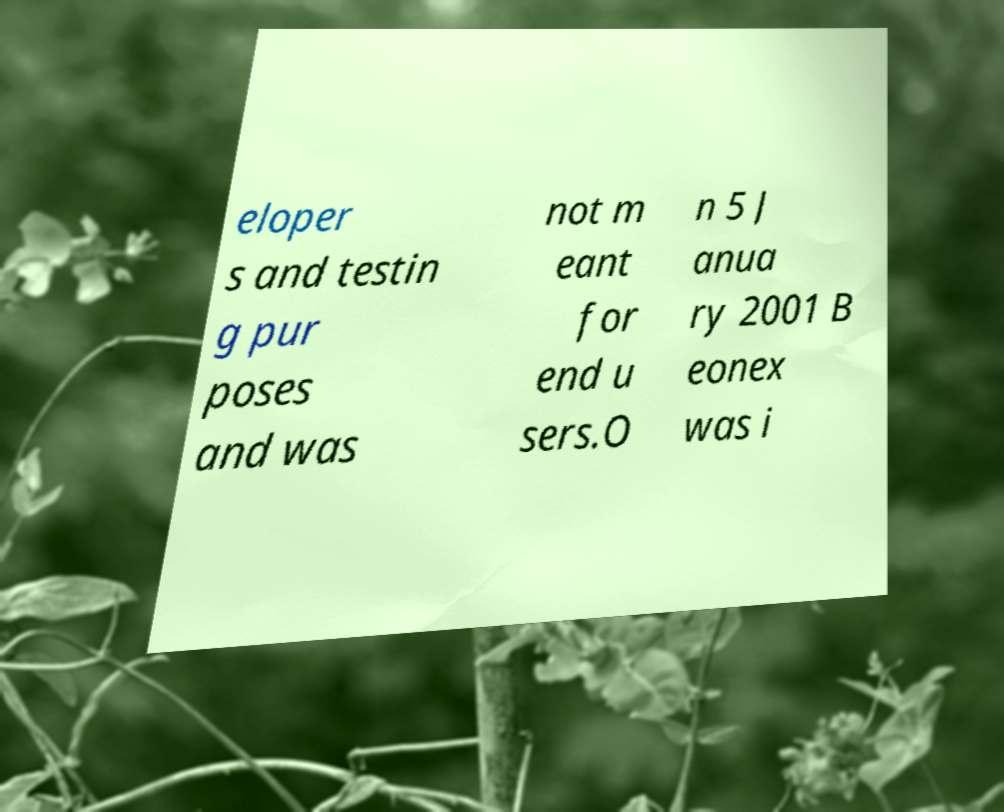Could you assist in decoding the text presented in this image and type it out clearly? eloper s and testin g pur poses and was not m eant for end u sers.O n 5 J anua ry 2001 B eonex was i 